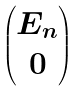Convert formula to latex. <formula><loc_0><loc_0><loc_500><loc_500>\begin{pmatrix} E _ { n } \\ 0 \end{pmatrix}</formula> 